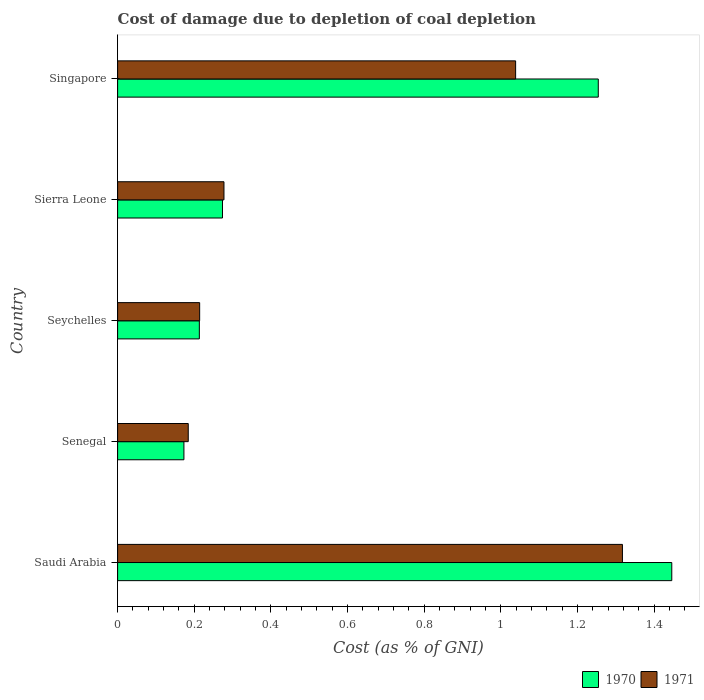How many groups of bars are there?
Your answer should be very brief. 5. Are the number of bars on each tick of the Y-axis equal?
Give a very brief answer. Yes. How many bars are there on the 5th tick from the top?
Provide a short and direct response. 2. How many bars are there on the 1st tick from the bottom?
Your answer should be compact. 2. What is the label of the 1st group of bars from the top?
Make the answer very short. Singapore. What is the cost of damage caused due to coal depletion in 1970 in Senegal?
Keep it short and to the point. 0.17. Across all countries, what is the maximum cost of damage caused due to coal depletion in 1970?
Offer a terse response. 1.45. Across all countries, what is the minimum cost of damage caused due to coal depletion in 1971?
Give a very brief answer. 0.18. In which country was the cost of damage caused due to coal depletion in 1970 maximum?
Ensure brevity in your answer.  Saudi Arabia. In which country was the cost of damage caused due to coal depletion in 1971 minimum?
Provide a short and direct response. Senegal. What is the total cost of damage caused due to coal depletion in 1970 in the graph?
Provide a short and direct response. 3.36. What is the difference between the cost of damage caused due to coal depletion in 1971 in Saudi Arabia and that in Seychelles?
Your response must be concise. 1.1. What is the difference between the cost of damage caused due to coal depletion in 1971 in Sierra Leone and the cost of damage caused due to coal depletion in 1970 in Senegal?
Your answer should be compact. 0.1. What is the average cost of damage caused due to coal depletion in 1971 per country?
Your response must be concise. 0.61. What is the difference between the cost of damage caused due to coal depletion in 1970 and cost of damage caused due to coal depletion in 1971 in Seychelles?
Offer a very short reply. -0. In how many countries, is the cost of damage caused due to coal depletion in 1970 greater than 0.2 %?
Give a very brief answer. 4. What is the ratio of the cost of damage caused due to coal depletion in 1970 in Senegal to that in Seychelles?
Give a very brief answer. 0.81. Is the difference between the cost of damage caused due to coal depletion in 1970 in Senegal and Seychelles greater than the difference between the cost of damage caused due to coal depletion in 1971 in Senegal and Seychelles?
Ensure brevity in your answer.  No. What is the difference between the highest and the second highest cost of damage caused due to coal depletion in 1970?
Ensure brevity in your answer.  0.19. What is the difference between the highest and the lowest cost of damage caused due to coal depletion in 1971?
Your answer should be very brief. 1.13. In how many countries, is the cost of damage caused due to coal depletion in 1970 greater than the average cost of damage caused due to coal depletion in 1970 taken over all countries?
Keep it short and to the point. 2. Is the sum of the cost of damage caused due to coal depletion in 1971 in Seychelles and Sierra Leone greater than the maximum cost of damage caused due to coal depletion in 1970 across all countries?
Make the answer very short. No. What does the 1st bar from the bottom in Senegal represents?
Your answer should be compact. 1970. How many bars are there?
Ensure brevity in your answer.  10. How many countries are there in the graph?
Offer a very short reply. 5. Does the graph contain any zero values?
Keep it short and to the point. No. Does the graph contain grids?
Your answer should be very brief. No. Where does the legend appear in the graph?
Offer a terse response. Bottom right. How many legend labels are there?
Offer a terse response. 2. What is the title of the graph?
Keep it short and to the point. Cost of damage due to depletion of coal depletion. Does "1986" appear as one of the legend labels in the graph?
Make the answer very short. No. What is the label or title of the X-axis?
Provide a short and direct response. Cost (as % of GNI). What is the Cost (as % of GNI) of 1970 in Saudi Arabia?
Your answer should be very brief. 1.45. What is the Cost (as % of GNI) in 1971 in Saudi Arabia?
Offer a very short reply. 1.32. What is the Cost (as % of GNI) of 1970 in Senegal?
Ensure brevity in your answer.  0.17. What is the Cost (as % of GNI) in 1971 in Senegal?
Give a very brief answer. 0.18. What is the Cost (as % of GNI) of 1970 in Seychelles?
Your answer should be very brief. 0.21. What is the Cost (as % of GNI) of 1971 in Seychelles?
Provide a succinct answer. 0.21. What is the Cost (as % of GNI) of 1970 in Sierra Leone?
Provide a short and direct response. 0.27. What is the Cost (as % of GNI) in 1971 in Sierra Leone?
Offer a terse response. 0.28. What is the Cost (as % of GNI) of 1970 in Singapore?
Your answer should be compact. 1.25. What is the Cost (as % of GNI) in 1971 in Singapore?
Your answer should be very brief. 1.04. Across all countries, what is the maximum Cost (as % of GNI) in 1970?
Keep it short and to the point. 1.45. Across all countries, what is the maximum Cost (as % of GNI) in 1971?
Provide a succinct answer. 1.32. Across all countries, what is the minimum Cost (as % of GNI) in 1970?
Offer a very short reply. 0.17. Across all countries, what is the minimum Cost (as % of GNI) of 1971?
Provide a short and direct response. 0.18. What is the total Cost (as % of GNI) in 1970 in the graph?
Make the answer very short. 3.36. What is the total Cost (as % of GNI) in 1971 in the graph?
Provide a short and direct response. 3.03. What is the difference between the Cost (as % of GNI) of 1970 in Saudi Arabia and that in Senegal?
Offer a terse response. 1.27. What is the difference between the Cost (as % of GNI) of 1971 in Saudi Arabia and that in Senegal?
Give a very brief answer. 1.13. What is the difference between the Cost (as % of GNI) in 1970 in Saudi Arabia and that in Seychelles?
Your answer should be very brief. 1.23. What is the difference between the Cost (as % of GNI) in 1971 in Saudi Arabia and that in Seychelles?
Offer a terse response. 1.1. What is the difference between the Cost (as % of GNI) of 1970 in Saudi Arabia and that in Sierra Leone?
Offer a terse response. 1.17. What is the difference between the Cost (as % of GNI) of 1971 in Saudi Arabia and that in Sierra Leone?
Keep it short and to the point. 1.04. What is the difference between the Cost (as % of GNI) of 1970 in Saudi Arabia and that in Singapore?
Your answer should be very brief. 0.19. What is the difference between the Cost (as % of GNI) in 1971 in Saudi Arabia and that in Singapore?
Give a very brief answer. 0.28. What is the difference between the Cost (as % of GNI) of 1970 in Senegal and that in Seychelles?
Give a very brief answer. -0.04. What is the difference between the Cost (as % of GNI) of 1971 in Senegal and that in Seychelles?
Provide a short and direct response. -0.03. What is the difference between the Cost (as % of GNI) of 1970 in Senegal and that in Sierra Leone?
Keep it short and to the point. -0.1. What is the difference between the Cost (as % of GNI) of 1971 in Senegal and that in Sierra Leone?
Provide a short and direct response. -0.09. What is the difference between the Cost (as % of GNI) in 1970 in Senegal and that in Singapore?
Offer a very short reply. -1.08. What is the difference between the Cost (as % of GNI) in 1971 in Senegal and that in Singapore?
Offer a terse response. -0.85. What is the difference between the Cost (as % of GNI) of 1970 in Seychelles and that in Sierra Leone?
Offer a terse response. -0.06. What is the difference between the Cost (as % of GNI) of 1971 in Seychelles and that in Sierra Leone?
Your answer should be very brief. -0.06. What is the difference between the Cost (as % of GNI) of 1970 in Seychelles and that in Singapore?
Keep it short and to the point. -1.04. What is the difference between the Cost (as % of GNI) of 1971 in Seychelles and that in Singapore?
Your answer should be compact. -0.82. What is the difference between the Cost (as % of GNI) of 1970 in Sierra Leone and that in Singapore?
Provide a short and direct response. -0.98. What is the difference between the Cost (as % of GNI) in 1971 in Sierra Leone and that in Singapore?
Your response must be concise. -0.76. What is the difference between the Cost (as % of GNI) in 1970 in Saudi Arabia and the Cost (as % of GNI) in 1971 in Senegal?
Ensure brevity in your answer.  1.26. What is the difference between the Cost (as % of GNI) of 1970 in Saudi Arabia and the Cost (as % of GNI) of 1971 in Seychelles?
Provide a short and direct response. 1.23. What is the difference between the Cost (as % of GNI) of 1970 in Saudi Arabia and the Cost (as % of GNI) of 1971 in Sierra Leone?
Give a very brief answer. 1.17. What is the difference between the Cost (as % of GNI) in 1970 in Saudi Arabia and the Cost (as % of GNI) in 1971 in Singapore?
Make the answer very short. 0.41. What is the difference between the Cost (as % of GNI) in 1970 in Senegal and the Cost (as % of GNI) in 1971 in Seychelles?
Give a very brief answer. -0.04. What is the difference between the Cost (as % of GNI) in 1970 in Senegal and the Cost (as % of GNI) in 1971 in Sierra Leone?
Offer a terse response. -0.1. What is the difference between the Cost (as % of GNI) in 1970 in Senegal and the Cost (as % of GNI) in 1971 in Singapore?
Your answer should be compact. -0.87. What is the difference between the Cost (as % of GNI) in 1970 in Seychelles and the Cost (as % of GNI) in 1971 in Sierra Leone?
Your answer should be very brief. -0.06. What is the difference between the Cost (as % of GNI) in 1970 in Seychelles and the Cost (as % of GNI) in 1971 in Singapore?
Provide a succinct answer. -0.83. What is the difference between the Cost (as % of GNI) of 1970 in Sierra Leone and the Cost (as % of GNI) of 1971 in Singapore?
Give a very brief answer. -0.77. What is the average Cost (as % of GNI) in 1970 per country?
Your answer should be compact. 0.67. What is the average Cost (as % of GNI) in 1971 per country?
Offer a terse response. 0.61. What is the difference between the Cost (as % of GNI) in 1970 and Cost (as % of GNI) in 1971 in Saudi Arabia?
Offer a very short reply. 0.13. What is the difference between the Cost (as % of GNI) in 1970 and Cost (as % of GNI) in 1971 in Senegal?
Keep it short and to the point. -0.01. What is the difference between the Cost (as % of GNI) of 1970 and Cost (as % of GNI) of 1971 in Seychelles?
Offer a terse response. -0. What is the difference between the Cost (as % of GNI) in 1970 and Cost (as % of GNI) in 1971 in Sierra Leone?
Your response must be concise. -0. What is the difference between the Cost (as % of GNI) of 1970 and Cost (as % of GNI) of 1971 in Singapore?
Your answer should be very brief. 0.22. What is the ratio of the Cost (as % of GNI) of 1970 in Saudi Arabia to that in Senegal?
Provide a succinct answer. 8.36. What is the ratio of the Cost (as % of GNI) of 1971 in Saudi Arabia to that in Senegal?
Make the answer very short. 7.15. What is the ratio of the Cost (as % of GNI) of 1970 in Saudi Arabia to that in Seychelles?
Ensure brevity in your answer.  6.78. What is the ratio of the Cost (as % of GNI) of 1971 in Saudi Arabia to that in Seychelles?
Offer a very short reply. 6.15. What is the ratio of the Cost (as % of GNI) in 1970 in Saudi Arabia to that in Sierra Leone?
Provide a succinct answer. 5.28. What is the ratio of the Cost (as % of GNI) in 1971 in Saudi Arabia to that in Sierra Leone?
Keep it short and to the point. 4.75. What is the ratio of the Cost (as % of GNI) in 1970 in Saudi Arabia to that in Singapore?
Give a very brief answer. 1.15. What is the ratio of the Cost (as % of GNI) in 1971 in Saudi Arabia to that in Singapore?
Keep it short and to the point. 1.27. What is the ratio of the Cost (as % of GNI) in 1970 in Senegal to that in Seychelles?
Offer a terse response. 0.81. What is the ratio of the Cost (as % of GNI) in 1971 in Senegal to that in Seychelles?
Your answer should be compact. 0.86. What is the ratio of the Cost (as % of GNI) in 1970 in Senegal to that in Sierra Leone?
Ensure brevity in your answer.  0.63. What is the ratio of the Cost (as % of GNI) of 1971 in Senegal to that in Sierra Leone?
Ensure brevity in your answer.  0.66. What is the ratio of the Cost (as % of GNI) of 1970 in Senegal to that in Singapore?
Your answer should be very brief. 0.14. What is the ratio of the Cost (as % of GNI) of 1971 in Senegal to that in Singapore?
Keep it short and to the point. 0.18. What is the ratio of the Cost (as % of GNI) of 1970 in Seychelles to that in Sierra Leone?
Provide a short and direct response. 0.78. What is the ratio of the Cost (as % of GNI) in 1971 in Seychelles to that in Sierra Leone?
Provide a succinct answer. 0.77. What is the ratio of the Cost (as % of GNI) in 1970 in Seychelles to that in Singapore?
Provide a short and direct response. 0.17. What is the ratio of the Cost (as % of GNI) of 1971 in Seychelles to that in Singapore?
Make the answer very short. 0.21. What is the ratio of the Cost (as % of GNI) in 1970 in Sierra Leone to that in Singapore?
Offer a very short reply. 0.22. What is the ratio of the Cost (as % of GNI) in 1971 in Sierra Leone to that in Singapore?
Your answer should be very brief. 0.27. What is the difference between the highest and the second highest Cost (as % of GNI) in 1970?
Ensure brevity in your answer.  0.19. What is the difference between the highest and the second highest Cost (as % of GNI) of 1971?
Your answer should be very brief. 0.28. What is the difference between the highest and the lowest Cost (as % of GNI) of 1970?
Give a very brief answer. 1.27. What is the difference between the highest and the lowest Cost (as % of GNI) of 1971?
Offer a very short reply. 1.13. 